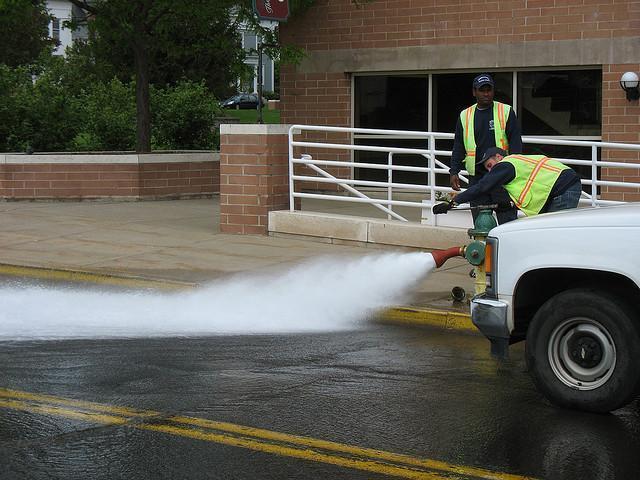How many people are in this picture?
Give a very brief answer. 2. How many people are there?
Give a very brief answer. 2. How many dogs has red plate?
Give a very brief answer. 0. 